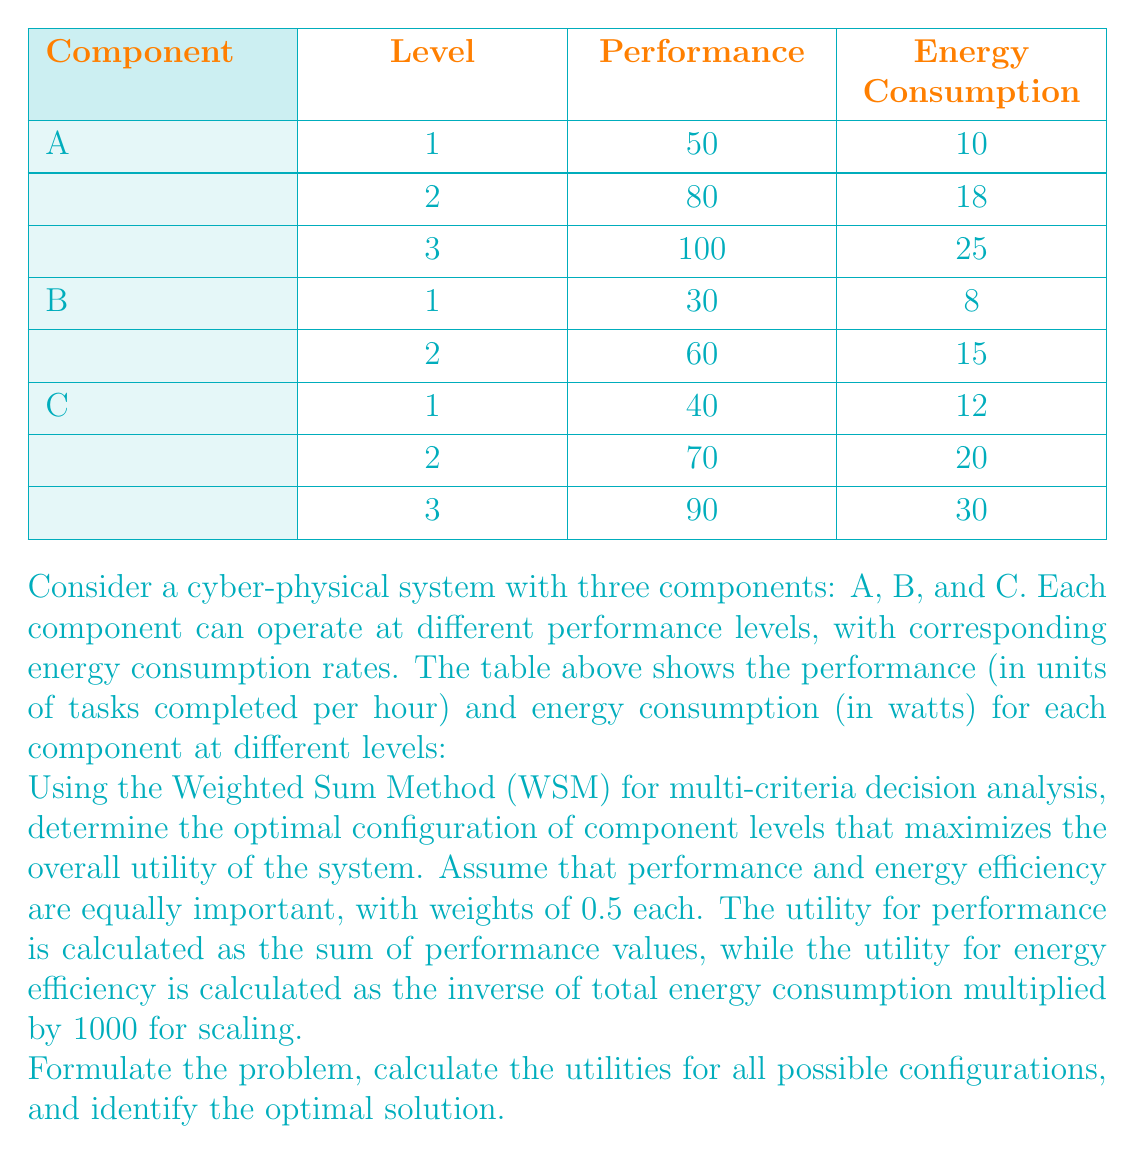Provide a solution to this math problem. To solve this problem, we'll follow these steps:

1. Identify all possible configurations
2. Calculate the total performance and energy consumption for each configuration
3. Calculate the utility scores for performance and energy efficiency
4. Apply the Weighted Sum Method to determine the overall utility
5. Identify the configuration with the highest overall utility

Step 1: Identify all possible configurations
There are 3 x 2 x 3 = 18 possible configurations, represented as (A level, B level, C level).

Step 2: Calculate total performance and energy consumption
For each configuration, we'll sum the performance values and energy consumption values.

Step 3: Calculate utility scores
Performance utility = Sum of performance values
Energy efficiency utility = 1000 / Total energy consumption

Step 4: Apply the Weighted Sum Method
Overall utility = 0.5 * Performance utility + 0.5 * Energy efficiency utility

Step 5: Identify the optimal configuration
We'll calculate the overall utility for each configuration and select the one with the highest value.

Calculations for all 18 configurations:

1. (1,1,1): Performance = 120, Energy = 30
   Utility = 0.5 * 120 + 0.5 * (1000/30) = 60 + 16.67 = 76.67

2. (1,1,2): Performance = 150, Energy = 38
   Utility = 0.5 * 150 + 0.5 * (1000/38) = 75 + 13.16 = 88.16

3. (1,1,3): Performance = 170, Energy = 48
   Utility = 0.5 * 170 + 0.5 * (1000/48) = 85 + 10.42 = 95.42

4. (1,2,1): Performance = 150, Energy = 37
   Utility = 0.5 * 150 + 0.5 * (1000/37) = 75 + 13.51 = 88.51

5. (1,2,2): Performance = 180, Energy = 45
   Utility = 0.5 * 180 + 0.5 * (1000/45) = 90 + 11.11 = 101.11

6. (1,2,3): Performance = 200, Energy = 55
   Utility = 0.5 * 200 + 0.5 * (1000/55) = 100 + 9.09 = 109.09

7. (2,1,1): Performance = 150, Energy = 38
   Utility = 0.5 * 150 + 0.5 * (1000/38) = 75 + 13.16 = 88.16

8. (2,1,2): Performance = 180, Energy = 46
   Utility = 0.5 * 180 + 0.5 * (1000/46) = 90 + 10.87 = 100.87

9. (2,1,3): Performance = 200, Energy = 56
   Utility = 0.5 * 200 + 0.5 * (1000/56) = 100 + 8.93 = 108.93

10. (2,2,1): Performance = 180, Energy = 45
    Utility = 0.5 * 180 + 0.5 * (1000/45) = 90 + 11.11 = 101.11

11. (2,2,2): Performance = 210, Energy = 53
    Utility = 0.5 * 210 + 0.5 * (1000/53) = 105 + 9.43 = 114.43

12. (2,2,3): Performance = 230, Energy = 63
    Utility = 0.5 * 230 + 0.5 * (1000/63) = 115 + 7.94 = 122.94

13. (3,1,1): Performance = 170, Energy = 45
    Utility = 0.5 * 170 + 0.5 * (1000/45) = 85 + 11.11 = 96.11

14. (3,1,2): Performance = 200, Energy = 53
    Utility = 0.5 * 200 + 0.5 * (1000/53) = 100 + 9.43 = 109.43

15. (3,1,3): Performance = 220, Energy = 63
    Utility = 0.5 * 220 + 0.5 * (1000/63) = 110 + 7.94 = 117.94

16. (3,2,1): Performance = 200, Energy = 52
    Utility = 0.5 * 200 + 0.5 * (1000/52) = 100 + 9.62 = 109.62

17. (3,2,2): Performance = 230, Energy = 60
    Utility = 0.5 * 230 + 0.5 * (1000/60) = 115 + 8.33 = 123.33

18. (3,2,3): Performance = 250, Energy = 70
    Utility = 0.5 * 250 + 0.5 * (1000/70) = 125 + 7.14 = 132.14

The highest overall utility is 132.14, corresponding to configuration (3,2,3).
Answer: The optimal configuration is (3,2,3), meaning:
- Component A at level 3 (Performance: 100, Energy: 25)
- Component B at level 2 (Performance: 60, Energy: 15)
- Component C at level 3 (Performance: 90, Energy: 30)

This configuration yields a total performance of 250 tasks per hour and a total energy consumption of 70 watts, resulting in the highest overall utility of 132.14. 